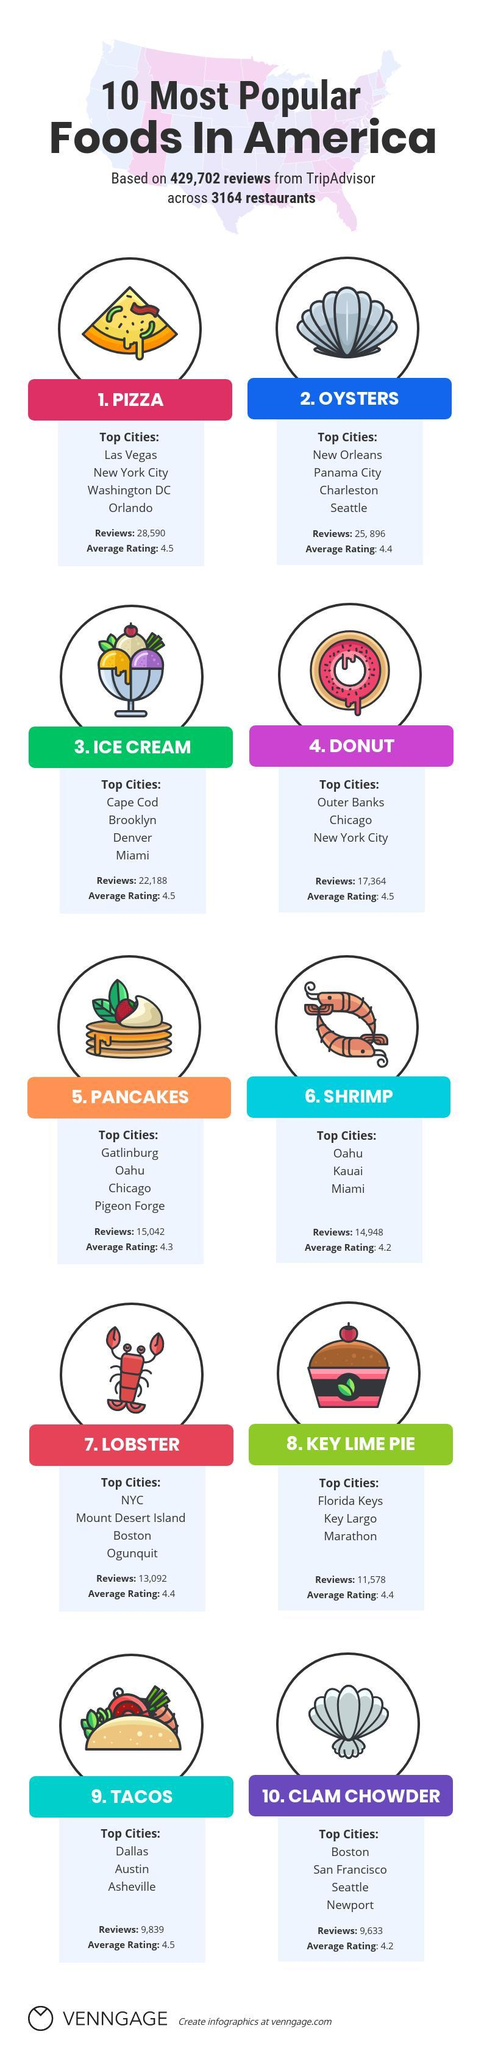What is the number of reviews for food with average rating 4.3?
Answer the question with a short phrase. 15,042 Which city likes to have  shrimps and ice creams? Miami Which city prefers lobsters, pizza and donuts? New York City Which food has higher number of food reviews, Ice cream, Pizza, or Donuts? Pizza Which food has the lowest average rating on Trip advisor? Clam Chowder, Shrimps Which of these foods have the same rating, Tacos, Pancakes, Pizza, Donuts? Tacos, Pizza, Donuts What are the popular foods in Seattle? Oysters, Clam Chowder Which foods have an average rating of 4.4? Oysters, Lobsters, Key Lime Pie 